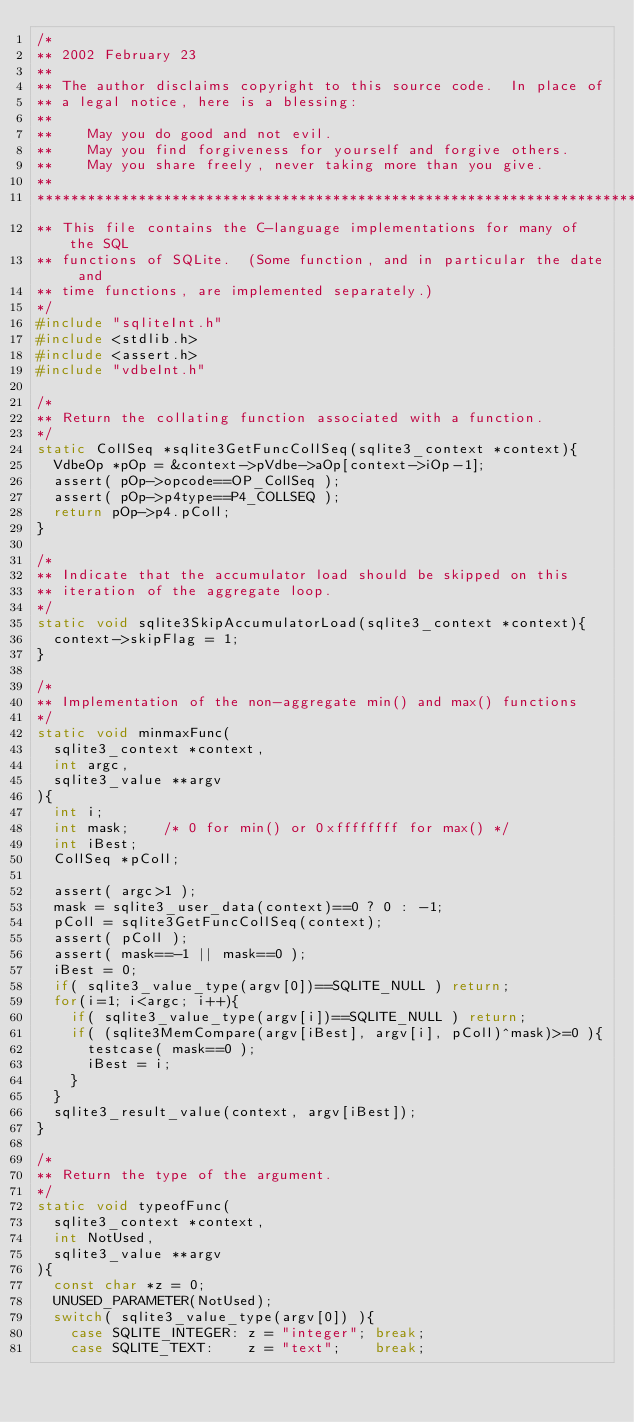Convert code to text. <code><loc_0><loc_0><loc_500><loc_500><_C_>/*
** 2002 February 23
**
** The author disclaims copyright to this source code.  In place of
** a legal notice, here is a blessing:
**
**    May you do good and not evil.
**    May you find forgiveness for yourself and forgive others.
**    May you share freely, never taking more than you give.
**
*************************************************************************
** This file contains the C-language implementations for many of the SQL
** functions of SQLite.  (Some function, and in particular the date and
** time functions, are implemented separately.)
*/
#include "sqliteInt.h"
#include <stdlib.h>
#include <assert.h>
#include "vdbeInt.h"

/*
** Return the collating function associated with a function.
*/
static CollSeq *sqlite3GetFuncCollSeq(sqlite3_context *context){
  VdbeOp *pOp = &context->pVdbe->aOp[context->iOp-1];
  assert( pOp->opcode==OP_CollSeq );
  assert( pOp->p4type==P4_COLLSEQ );
  return pOp->p4.pColl;
}

/*
** Indicate that the accumulator load should be skipped on this
** iteration of the aggregate loop.
*/
static void sqlite3SkipAccumulatorLoad(sqlite3_context *context){
  context->skipFlag = 1;
}

/*
** Implementation of the non-aggregate min() and max() functions
*/
static void minmaxFunc(
  sqlite3_context *context,
  int argc,
  sqlite3_value **argv
){
  int i;
  int mask;    /* 0 for min() or 0xffffffff for max() */
  int iBest;
  CollSeq *pColl;

  assert( argc>1 );
  mask = sqlite3_user_data(context)==0 ? 0 : -1;
  pColl = sqlite3GetFuncCollSeq(context);
  assert( pColl );
  assert( mask==-1 || mask==0 );
  iBest = 0;
  if( sqlite3_value_type(argv[0])==SQLITE_NULL ) return;
  for(i=1; i<argc; i++){
    if( sqlite3_value_type(argv[i])==SQLITE_NULL ) return;
    if( (sqlite3MemCompare(argv[iBest], argv[i], pColl)^mask)>=0 ){
      testcase( mask==0 );
      iBest = i;
    }
  }
  sqlite3_result_value(context, argv[iBest]);
}

/*
** Return the type of the argument.
*/
static void typeofFunc(
  sqlite3_context *context,
  int NotUsed,
  sqlite3_value **argv
){
  const char *z = 0;
  UNUSED_PARAMETER(NotUsed);
  switch( sqlite3_value_type(argv[0]) ){
    case SQLITE_INTEGER: z = "integer"; break;
    case SQLITE_TEXT:    z = "text";    break;</code> 